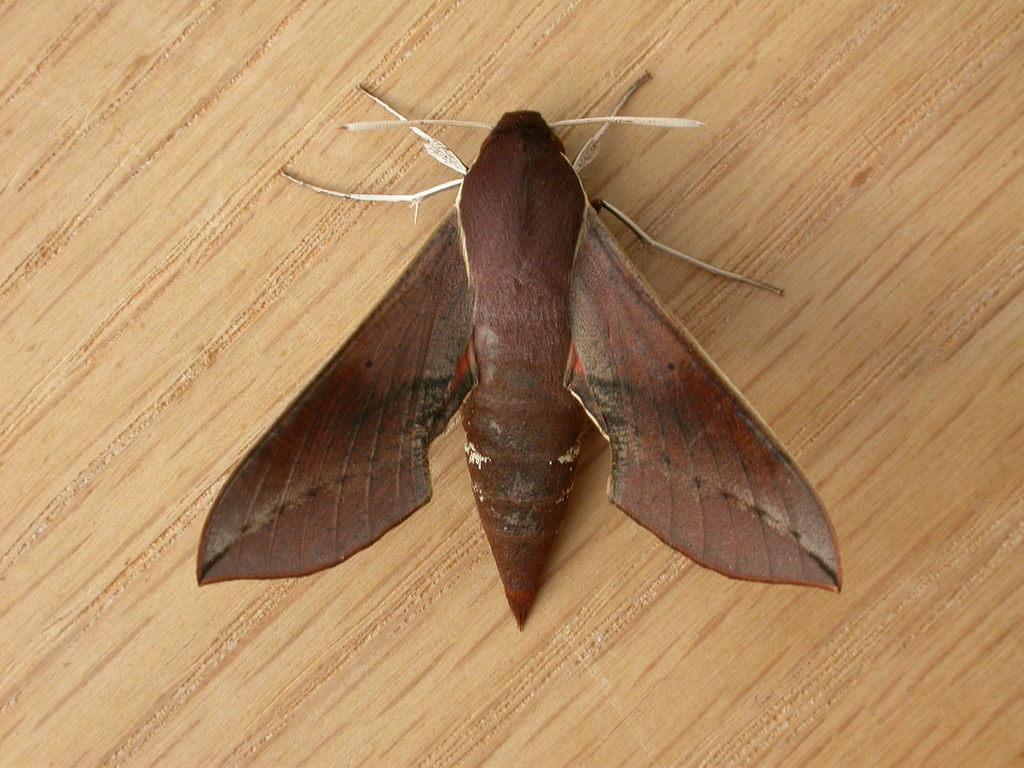Can you describe this image briefly? In this picture we can see brown butterfly sitting on the wooden table top. 